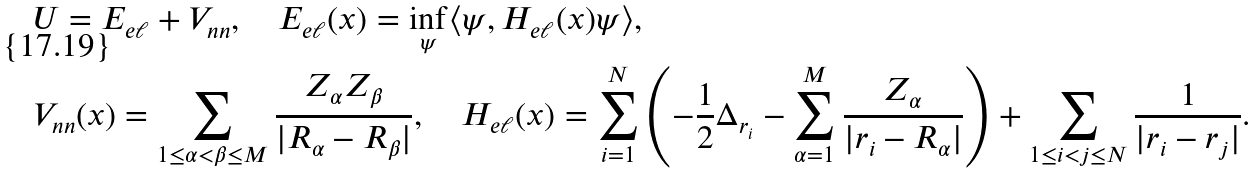<formula> <loc_0><loc_0><loc_500><loc_500>& U = E _ { e \ell } + V _ { n n } , \quad E _ { e \ell } ( x ) = \inf _ { \psi } \langle \psi , H _ { e \ell } ( x ) \psi \rangle , \\ & V _ { n n } ( x ) = \sum _ { 1 \leq \alpha < \beta \leq M } \frac { Z _ { \alpha } Z _ { \beta } } { | R _ { \alpha } - R _ { \beta } | } , \quad H _ { e \ell } ( x ) = \sum _ { i = 1 } ^ { N } \left ( - \frac { 1 } { 2 } \Delta _ { r _ { i } } - \sum _ { \alpha = 1 } ^ { M } \frac { Z _ { \alpha } } { | r _ { i } - R _ { \alpha } | } \right ) + \sum _ { 1 \leq i < j \leq N } \frac { 1 } { | r _ { i } - r _ { j } | } .</formula> 